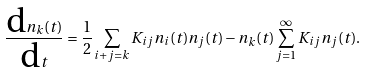Convert formula to latex. <formula><loc_0><loc_0><loc_500><loc_500>\frac { \text {d} n _ { k } ( t ) } { \text {d} t } = \frac { 1 } { 2 } \sum _ { i + j = k } K _ { i j } n _ { i } ( t ) n _ { j } ( t ) - n _ { k } ( t ) \sum _ { j = 1 } ^ { \infty } K _ { i j } n _ { j } ( t ) .</formula> 